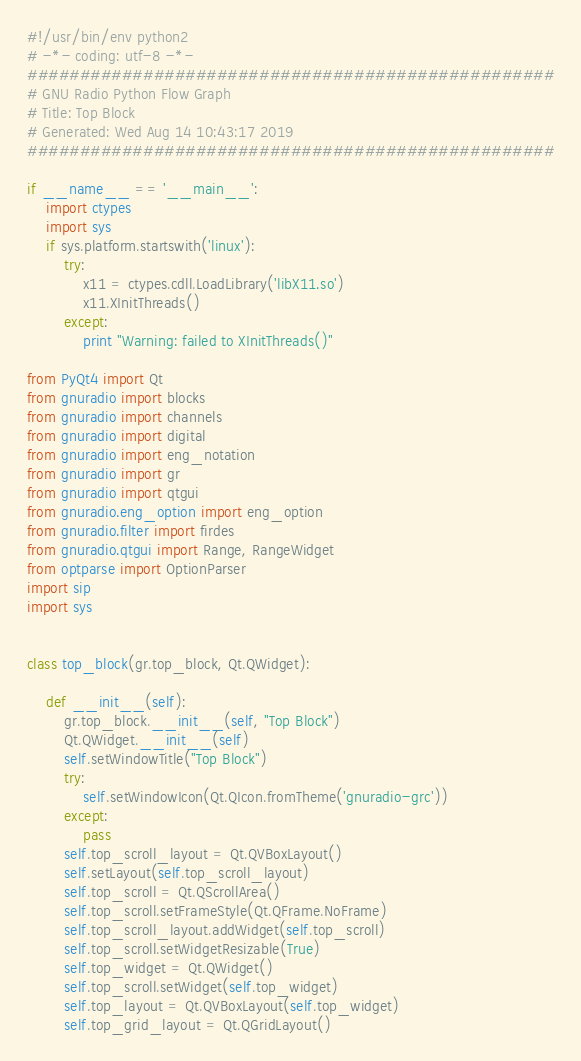<code> <loc_0><loc_0><loc_500><loc_500><_Python_>#!/usr/bin/env python2
# -*- coding: utf-8 -*-
##################################################
# GNU Radio Python Flow Graph
# Title: Top Block
# Generated: Wed Aug 14 10:43:17 2019
##################################################

if __name__ == '__main__':
    import ctypes
    import sys
    if sys.platform.startswith('linux'):
        try:
            x11 = ctypes.cdll.LoadLibrary('libX11.so')
            x11.XInitThreads()
        except:
            print "Warning: failed to XInitThreads()"

from PyQt4 import Qt
from gnuradio import blocks
from gnuradio import channels
from gnuradio import digital
from gnuradio import eng_notation
from gnuradio import gr
from gnuradio import qtgui
from gnuradio.eng_option import eng_option
from gnuradio.filter import firdes
from gnuradio.qtgui import Range, RangeWidget
from optparse import OptionParser
import sip
import sys


class top_block(gr.top_block, Qt.QWidget):

    def __init__(self):
        gr.top_block.__init__(self, "Top Block")
        Qt.QWidget.__init__(self)
        self.setWindowTitle("Top Block")
        try:
            self.setWindowIcon(Qt.QIcon.fromTheme('gnuradio-grc'))
        except:
            pass
        self.top_scroll_layout = Qt.QVBoxLayout()
        self.setLayout(self.top_scroll_layout)
        self.top_scroll = Qt.QScrollArea()
        self.top_scroll.setFrameStyle(Qt.QFrame.NoFrame)
        self.top_scroll_layout.addWidget(self.top_scroll)
        self.top_scroll.setWidgetResizable(True)
        self.top_widget = Qt.QWidget()
        self.top_scroll.setWidget(self.top_widget)
        self.top_layout = Qt.QVBoxLayout(self.top_widget)
        self.top_grid_layout = Qt.QGridLayout()</code> 